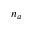<formula> <loc_0><loc_0><loc_500><loc_500>n _ { a }</formula> 